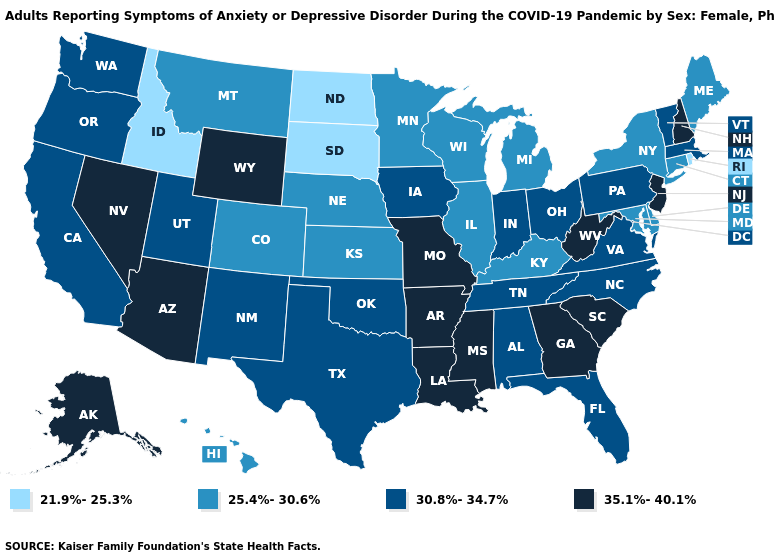Among the states that border Utah , which have the lowest value?
Be succinct. Idaho. What is the value of Michigan?
Concise answer only. 25.4%-30.6%. Does the map have missing data?
Give a very brief answer. No. What is the value of Maine?
Write a very short answer. 25.4%-30.6%. What is the lowest value in the USA?
Quick response, please. 21.9%-25.3%. What is the value of Georgia?
Keep it brief. 35.1%-40.1%. What is the value of Washington?
Short answer required. 30.8%-34.7%. Among the states that border Indiana , which have the highest value?
Short answer required. Ohio. How many symbols are there in the legend?
Answer briefly. 4. Does New Jersey have the highest value in the Northeast?
Short answer required. Yes. What is the value of Michigan?
Concise answer only. 25.4%-30.6%. Does the first symbol in the legend represent the smallest category?
Be succinct. Yes. Name the states that have a value in the range 30.8%-34.7%?
Quick response, please. Alabama, California, Florida, Indiana, Iowa, Massachusetts, New Mexico, North Carolina, Ohio, Oklahoma, Oregon, Pennsylvania, Tennessee, Texas, Utah, Vermont, Virginia, Washington. Name the states that have a value in the range 21.9%-25.3%?
Keep it brief. Idaho, North Dakota, Rhode Island, South Dakota. What is the value of Louisiana?
Answer briefly. 35.1%-40.1%. 